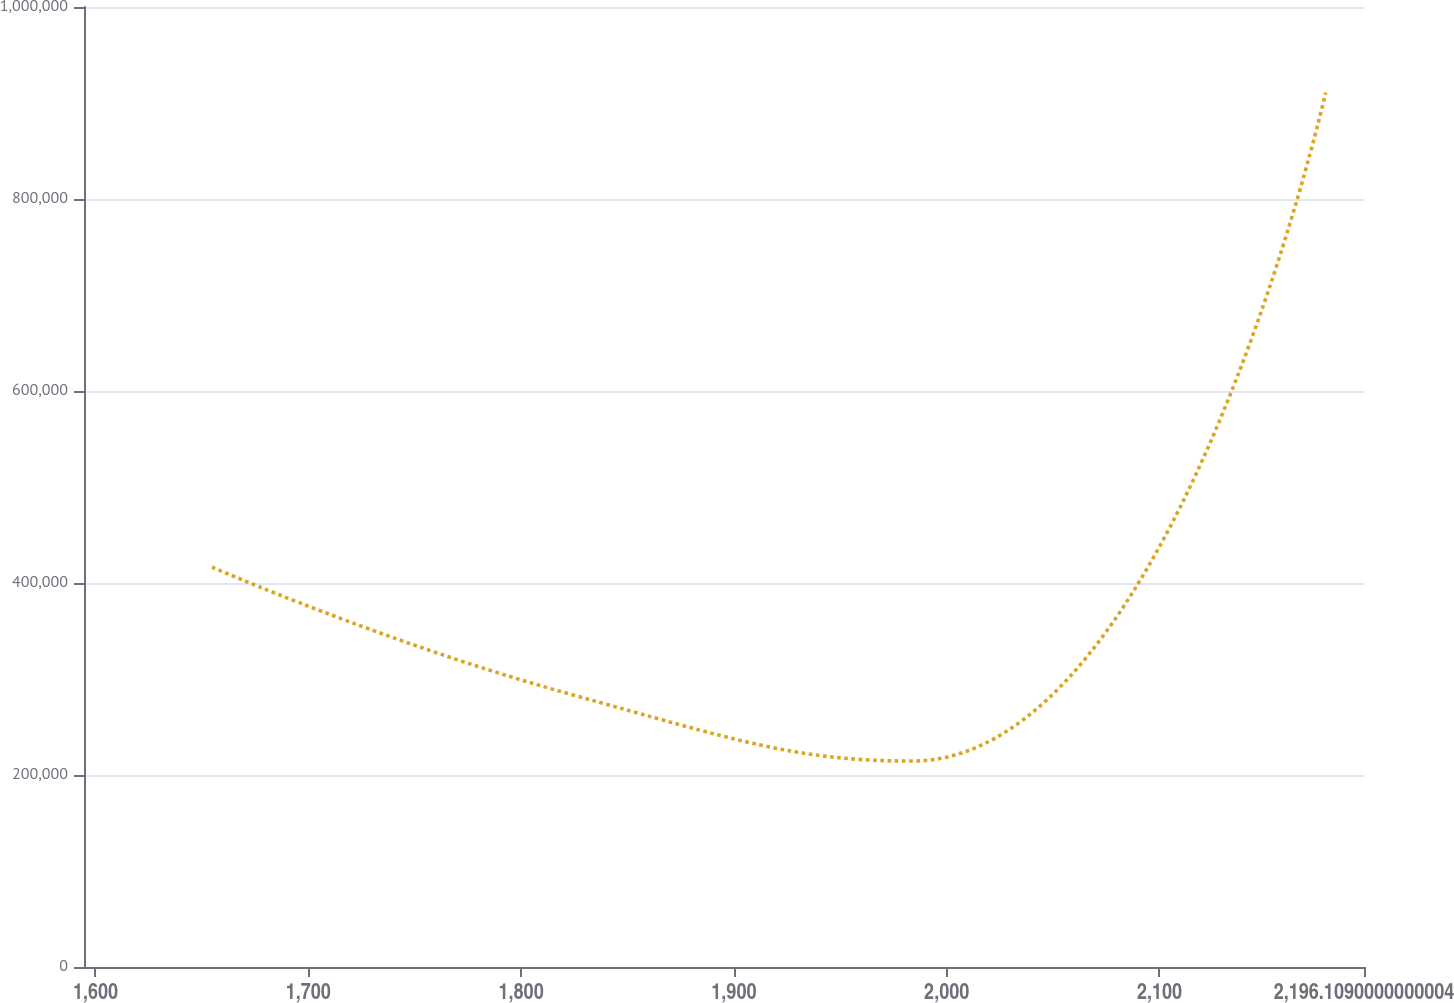<chart> <loc_0><loc_0><loc_500><loc_500><line_chart><ecel><fcel>Unnamed: 1<nl><fcel>1654.75<fcel>416552<nl><fcel>1823.15<fcel>284145<nl><fcel>1983.68<fcel>214518<nl><fcel>2178.09<fcel>910788<nl><fcel>2256.26<fcel>604819<nl></chart> 